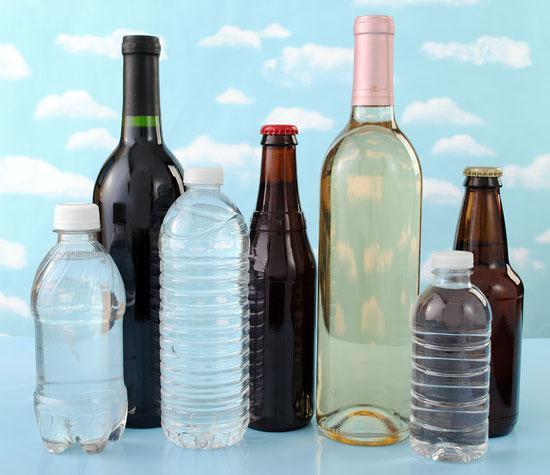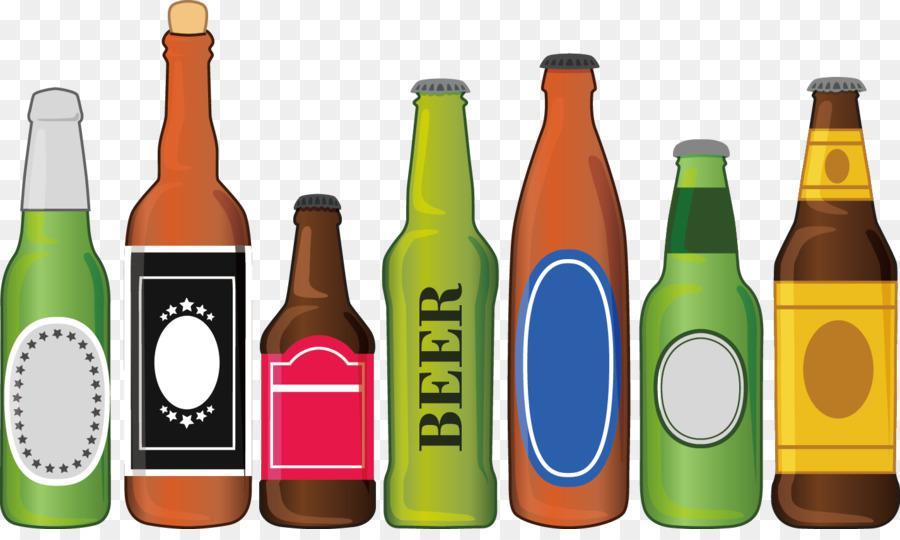The first image is the image on the left, the second image is the image on the right. For the images displayed, is the sentence "In at least one image there are nine bottles of alcohol." factually correct? Answer yes or no. No. 